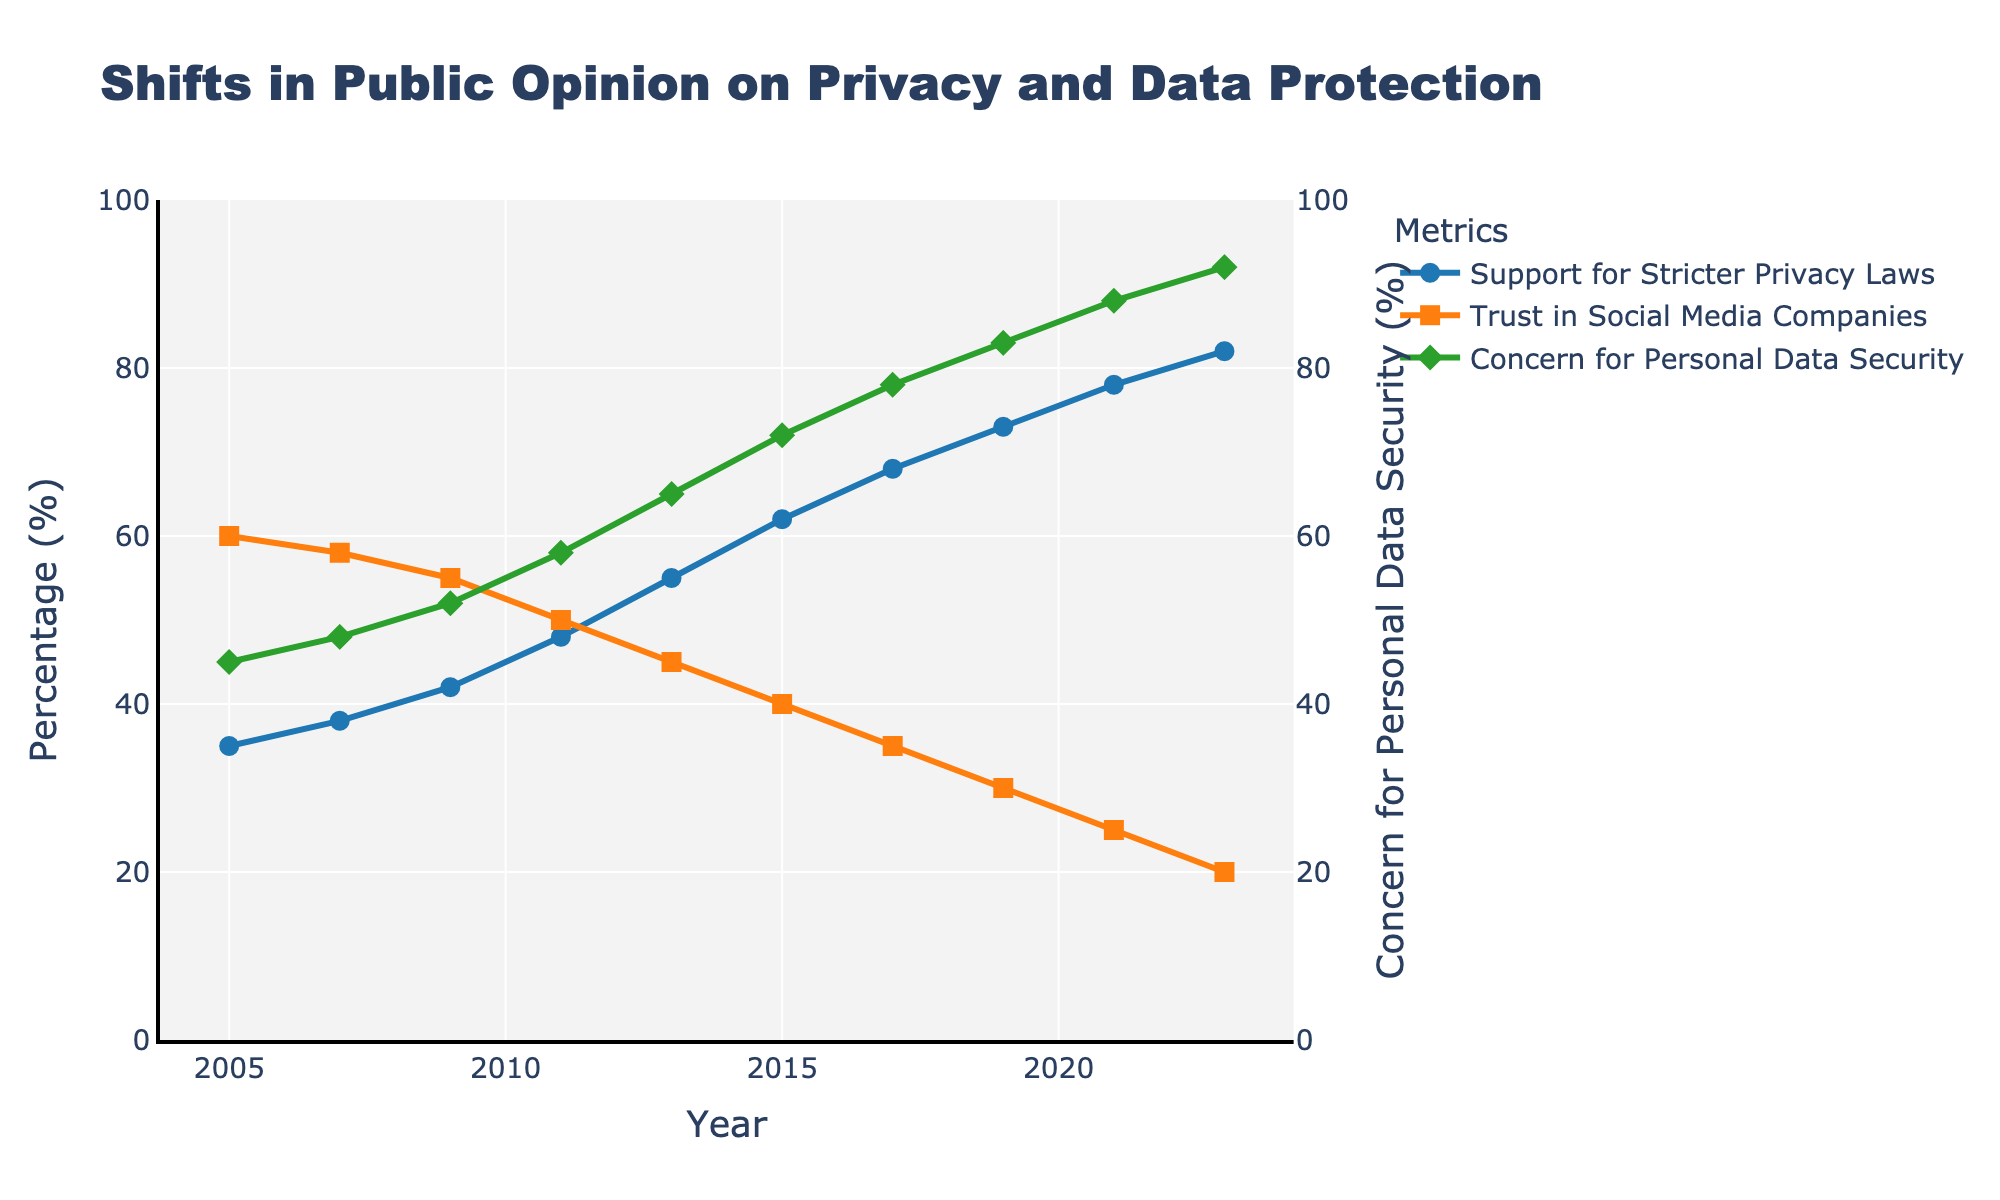What's the percentage increase in support for stricter privacy laws from 2005 to 2023? The support for stricter privacy laws in 2005 is 35%, and in 2023 it is 82%. The percentage increase can be calculated as ((82 - 35) / 35) * 100.
Answer: 134.29% In which year did the concern for personal data security surpass 75%? By examining the figure, observe the trend line for concern for personal data security and identify the year when it first exceeds 75%.
Answer: 2017 Which year has the highest trust in social media companies? Look at the line representing trust in social media companies and determine the year at its peak.
Answer: 2005 How many years did it take for support for stricter privacy laws to increase from 35% to 55%? Note the support values in 2005 (35%) and 2013 (55%). Subtract 2005 from 2013 to find the difference in years.
Answer: 8 Compare the trust in social media companies in 2005 and 2023. Has it increased or decreased? Check the trust in social media companies for the years 2005 and 2023. Trust in 2005 is 60%, and in 2023 it is 20%. Since 60 is greater than 20, it has decreased.
Answer: Decreased What is the average concern for personal data security from 2011 to 2023? Add the percentages for concern for personal data security for the years 2011 (58%), 2013 (65%), 2015 (72%), 2017 (78%), 2019 (83%), 2021 (88%), and 2023 (92%). Divide the total by the number of years. (58 + 65 + 72 + 78 + 83 + 88 + 92) / 7 = 76.57
Answer: 76.57 In which year is the gap between support for stricter privacy laws and trust in social media companies the largest? Calculate the difference each year between support for stricter privacy laws and trust in social media companies, then identify the maximum gap. The largest gap is in 2023: 82% - 20% = 62%.
Answer: 2023 What trend can be observed for trust in social media companies from 2005 to 2023? Observe the line representing trust in social media companies from 2005 to 2023 to see if it generally increases, decreases, or stays constant.
Answer: Decreasing How did the concern for personal data security change between 2019 and 2021? Check the percentages for the concern for personal data security in 2019 and 2021. It increased from 83% to 88%.
Answer: Increased 